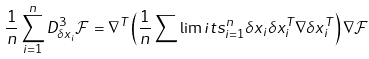<formula> <loc_0><loc_0><loc_500><loc_500>\frac { 1 } { n } \sum _ { i = 1 } ^ { n } D _ { \delta x _ { i } } ^ { 3 } \mathcal { F } = \nabla ^ { T } \left ( \frac { 1 } { n } \sum \lim i t s _ { i = 1 } ^ { n } \delta x _ { i } \delta x _ { i } ^ { T } \nabla \delta x _ { i } ^ { T } \right ) \nabla \mathcal { F }</formula> 